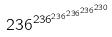Convert formula to latex. <formula><loc_0><loc_0><loc_500><loc_500>2 3 6 ^ { 2 3 6 ^ { 2 3 6 ^ { 2 3 6 ^ { 2 3 6 ^ { 2 3 0 } } } } }</formula> 